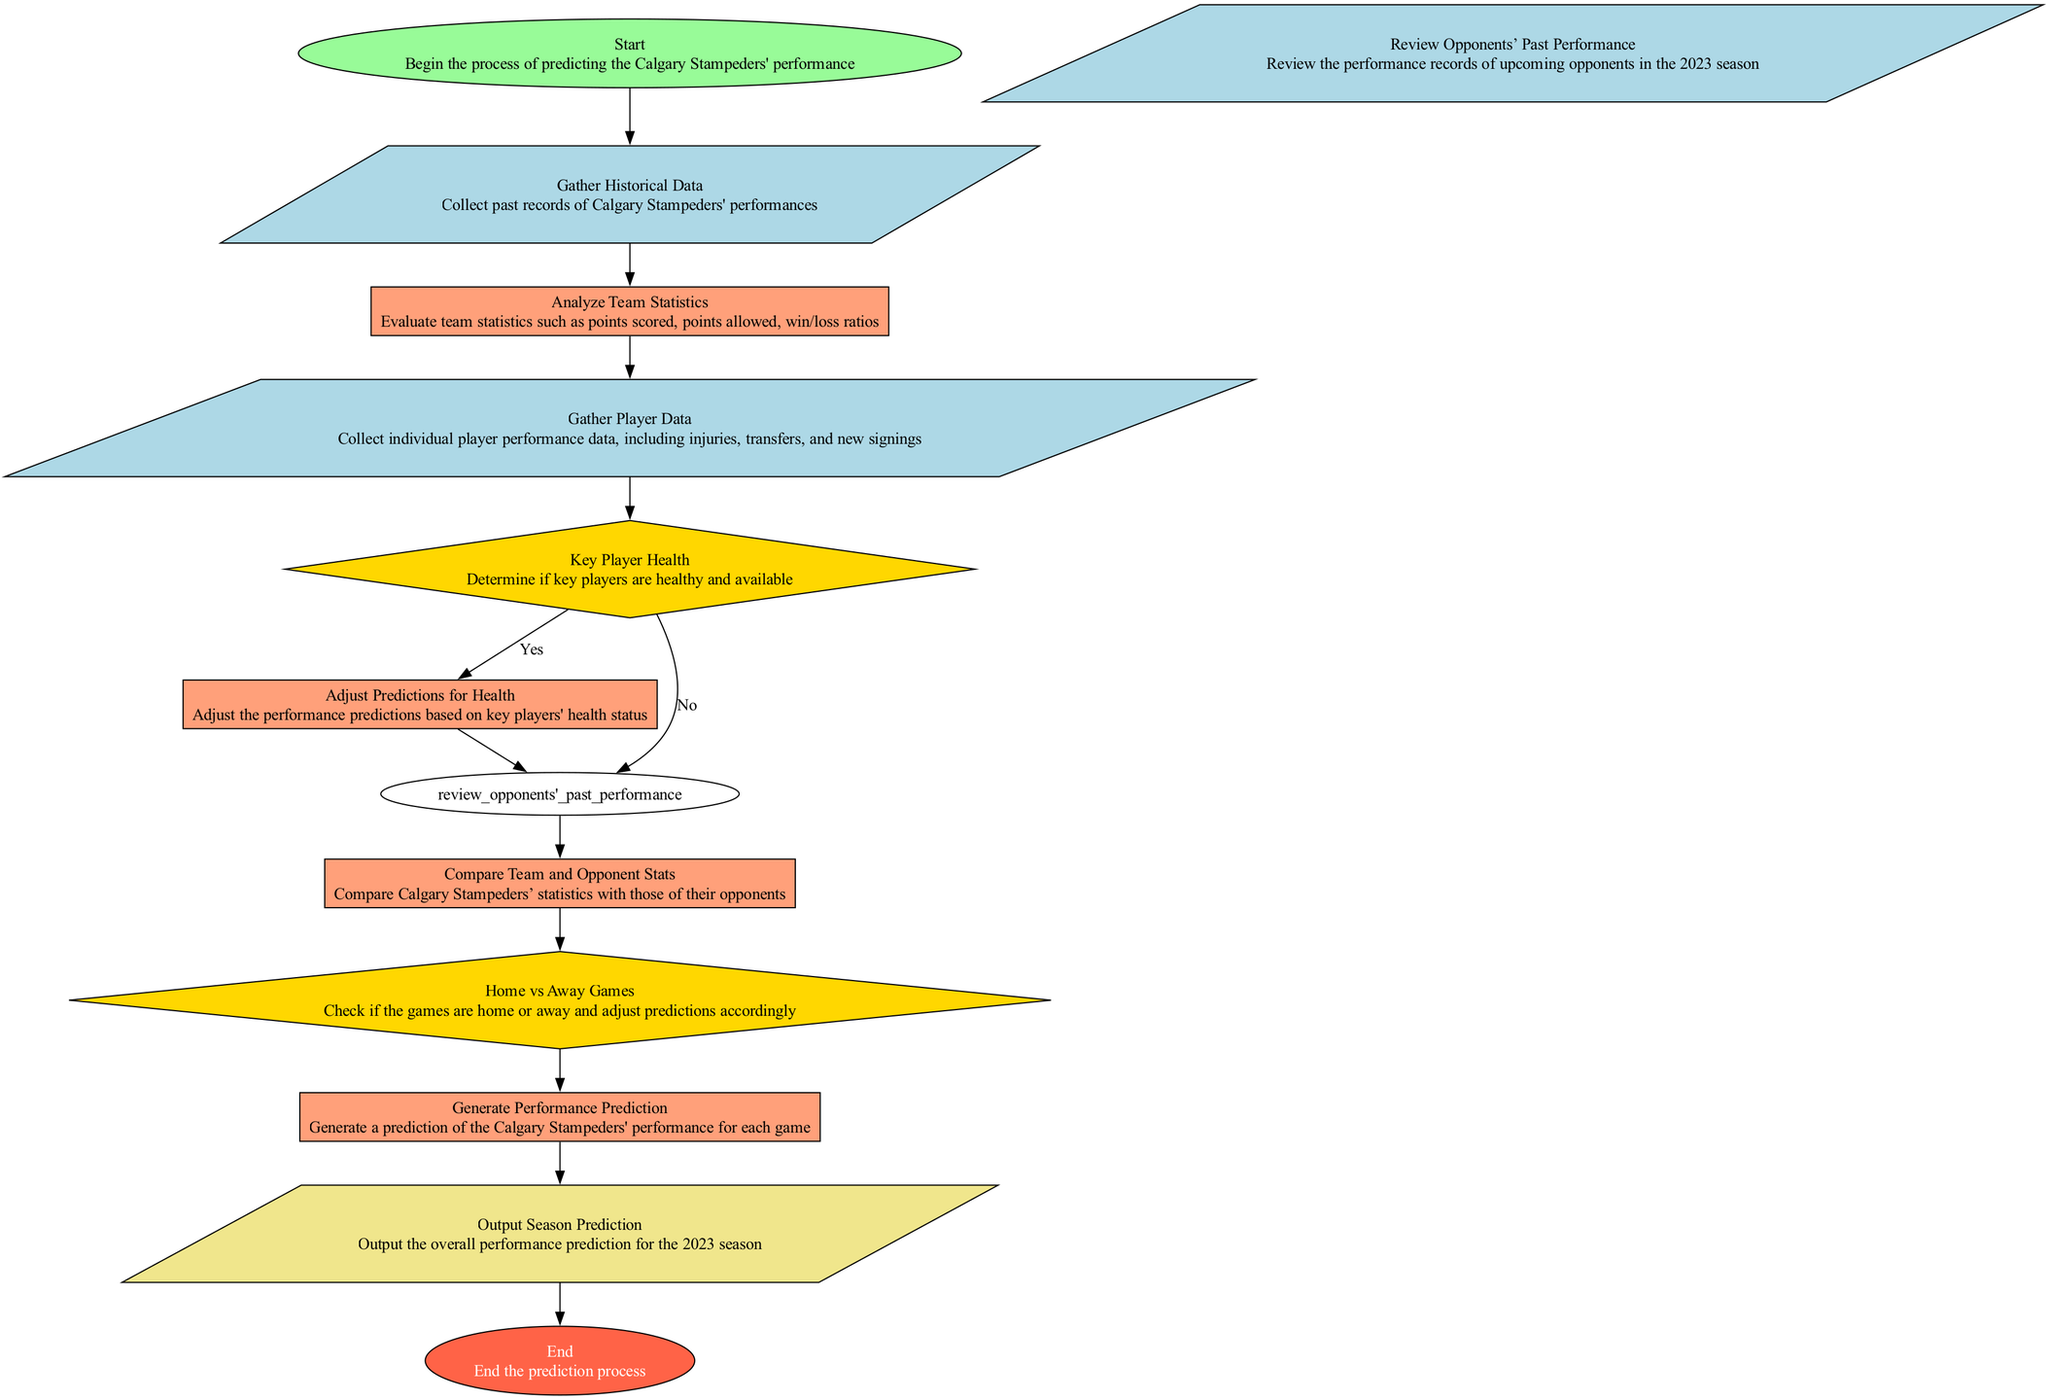What's the first step in the prediction process? The first step in the prediction process is 'Start', as indicated at the beginning of the flowchart.
Answer: Start How many input nodes are in the diagram? There are three input nodes: 'Gather Historical Data', 'Gather Player Data', and 'Review Opponents’ Past Performance'.
Answer: 3 What happens if key players are healthy? If key players are healthy, the diagram indicates that the flow moves to 'Adjust Predictions for Health'.
Answer: Adjust Predictions for Health Which process comes after analyzing team statistics? After 'Analyze Team Statistics', the next process is 'Gather Player Data', as indicated by the direction of the flowchart.
Answer: Gather Player Data What is the final output of the prediction process? The final output of the prediction process is 'Output Season Prediction', which reflects the overall performance prediction for the 2023 season.
Answer: Output Season Prediction What decision point occurs after gathering player data? The decision point that occurs after gathering player data is 'Key Player Health', where the health status of key players is evaluated.
Answer: Key Player Health How many processes are there in the diagram? There are five processes in the diagram: 'Analyze Team Statistics', 'Adjust Predictions for Health', 'Compare Team and Opponent Stats', 'Generate Performance Prediction', and 'Output Season Prediction'.
Answer: 5 What is checked in the decision point "Home vs Away Games"? In the decision point "Home vs Away Games", it is checked whether the games played are home or away, influencing the prediction adjustments.
Answer: Home or Away Which node involves reviewing the performance of opponents? The node that involves reviewing the performance of opponents is 'Review Opponents’ Past Performance', which is crucial for assessing competition.
Answer: Review Opponents’ Past Performance 